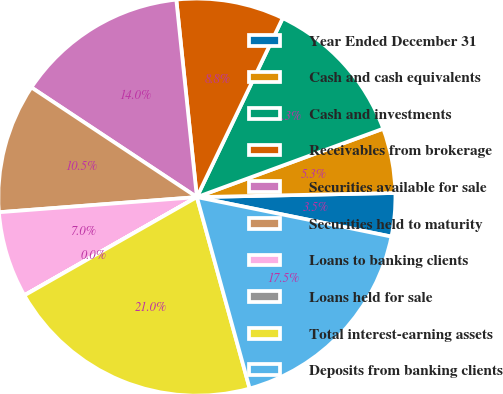<chart> <loc_0><loc_0><loc_500><loc_500><pie_chart><fcel>Year Ended December 31<fcel>Cash and cash equivalents<fcel>Cash and investments<fcel>Receivables from brokerage<fcel>Securities available for sale<fcel>Securities held to maturity<fcel>Loans to banking clients<fcel>Loans held for sale<fcel>Total interest-earning assets<fcel>Deposits from banking clients<nl><fcel>3.52%<fcel>5.27%<fcel>12.28%<fcel>8.77%<fcel>14.03%<fcel>10.53%<fcel>7.02%<fcel>0.01%<fcel>21.04%<fcel>17.53%<nl></chart> 